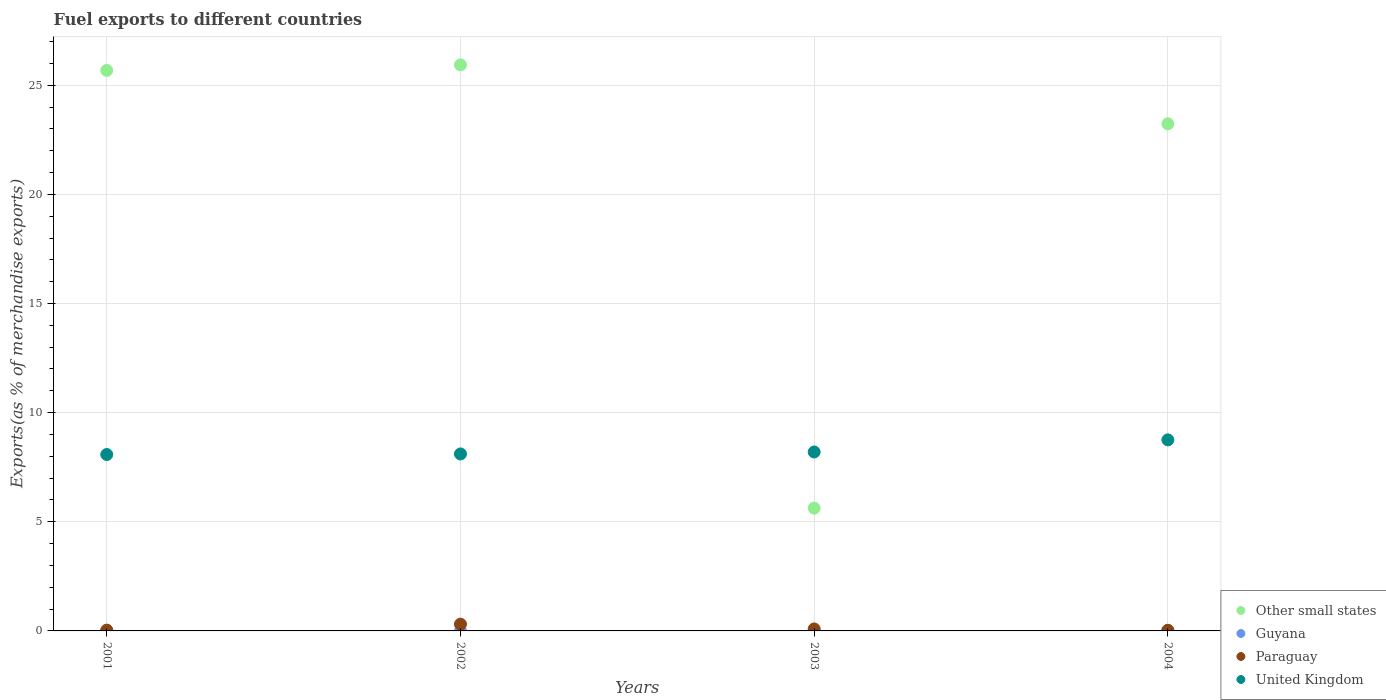What is the percentage of exports to different countries in Guyana in 2004?
Offer a terse response. 0.02. Across all years, what is the maximum percentage of exports to different countries in Guyana?
Your response must be concise. 0.02. Across all years, what is the minimum percentage of exports to different countries in Paraguay?
Your answer should be compact. 0.03. In which year was the percentage of exports to different countries in Guyana maximum?
Give a very brief answer. 2004. What is the total percentage of exports to different countries in United Kingdom in the graph?
Make the answer very short. 33.14. What is the difference between the percentage of exports to different countries in Paraguay in 2002 and that in 2004?
Ensure brevity in your answer.  0.28. What is the difference between the percentage of exports to different countries in Paraguay in 2002 and the percentage of exports to different countries in Other small states in 2001?
Offer a terse response. -25.37. What is the average percentage of exports to different countries in Paraguay per year?
Provide a succinct answer. 0.12. In the year 2003, what is the difference between the percentage of exports to different countries in Other small states and percentage of exports to different countries in Paraguay?
Make the answer very short. 5.53. What is the ratio of the percentage of exports to different countries in United Kingdom in 2002 to that in 2003?
Make the answer very short. 0.99. Is the difference between the percentage of exports to different countries in Other small states in 2001 and 2004 greater than the difference between the percentage of exports to different countries in Paraguay in 2001 and 2004?
Provide a succinct answer. Yes. What is the difference between the highest and the second highest percentage of exports to different countries in Paraguay?
Give a very brief answer. 0.22. What is the difference between the highest and the lowest percentage of exports to different countries in Guyana?
Your answer should be compact. 0.02. Is it the case that in every year, the sum of the percentage of exports to different countries in Guyana and percentage of exports to different countries in Paraguay  is greater than the sum of percentage of exports to different countries in Other small states and percentage of exports to different countries in United Kingdom?
Your answer should be very brief. No. Is it the case that in every year, the sum of the percentage of exports to different countries in Other small states and percentage of exports to different countries in Paraguay  is greater than the percentage of exports to different countries in United Kingdom?
Your answer should be compact. No. Does the percentage of exports to different countries in Paraguay monotonically increase over the years?
Offer a very short reply. No. Is the percentage of exports to different countries in Other small states strictly less than the percentage of exports to different countries in Guyana over the years?
Your answer should be very brief. No. How many years are there in the graph?
Offer a terse response. 4. What is the difference between two consecutive major ticks on the Y-axis?
Your answer should be compact. 5. Does the graph contain grids?
Provide a succinct answer. Yes. What is the title of the graph?
Give a very brief answer. Fuel exports to different countries. Does "Morocco" appear as one of the legend labels in the graph?
Make the answer very short. No. What is the label or title of the Y-axis?
Make the answer very short. Exports(as % of merchandise exports). What is the Exports(as % of merchandise exports) of Other small states in 2001?
Give a very brief answer. 25.68. What is the Exports(as % of merchandise exports) in Guyana in 2001?
Offer a very short reply. 0.01. What is the Exports(as % of merchandise exports) of Paraguay in 2001?
Give a very brief answer. 0.04. What is the Exports(as % of merchandise exports) of United Kingdom in 2001?
Offer a very short reply. 8.08. What is the Exports(as % of merchandise exports) in Other small states in 2002?
Provide a short and direct response. 25.93. What is the Exports(as % of merchandise exports) of Guyana in 2002?
Offer a terse response. 1.42119734312842e-5. What is the Exports(as % of merchandise exports) of Paraguay in 2002?
Make the answer very short. 0.31. What is the Exports(as % of merchandise exports) of United Kingdom in 2002?
Ensure brevity in your answer.  8.11. What is the Exports(as % of merchandise exports) in Other small states in 2003?
Your response must be concise. 5.63. What is the Exports(as % of merchandise exports) in Guyana in 2003?
Keep it short and to the point. 0. What is the Exports(as % of merchandise exports) in Paraguay in 2003?
Make the answer very short. 0.09. What is the Exports(as % of merchandise exports) in United Kingdom in 2003?
Offer a terse response. 8.2. What is the Exports(as % of merchandise exports) of Other small states in 2004?
Offer a very short reply. 23.23. What is the Exports(as % of merchandise exports) in Guyana in 2004?
Ensure brevity in your answer.  0.02. What is the Exports(as % of merchandise exports) of Paraguay in 2004?
Give a very brief answer. 0.03. What is the Exports(as % of merchandise exports) of United Kingdom in 2004?
Provide a succinct answer. 8.75. Across all years, what is the maximum Exports(as % of merchandise exports) of Other small states?
Give a very brief answer. 25.93. Across all years, what is the maximum Exports(as % of merchandise exports) of Guyana?
Give a very brief answer. 0.02. Across all years, what is the maximum Exports(as % of merchandise exports) in Paraguay?
Your answer should be very brief. 0.31. Across all years, what is the maximum Exports(as % of merchandise exports) of United Kingdom?
Make the answer very short. 8.75. Across all years, what is the minimum Exports(as % of merchandise exports) of Other small states?
Offer a terse response. 5.63. Across all years, what is the minimum Exports(as % of merchandise exports) of Guyana?
Provide a short and direct response. 1.42119734312842e-5. Across all years, what is the minimum Exports(as % of merchandise exports) of Paraguay?
Provide a short and direct response. 0.03. Across all years, what is the minimum Exports(as % of merchandise exports) of United Kingdom?
Your answer should be very brief. 8.08. What is the total Exports(as % of merchandise exports) in Other small states in the graph?
Provide a succinct answer. 80.47. What is the total Exports(as % of merchandise exports) in Guyana in the graph?
Ensure brevity in your answer.  0.03. What is the total Exports(as % of merchandise exports) in Paraguay in the graph?
Provide a succinct answer. 0.47. What is the total Exports(as % of merchandise exports) of United Kingdom in the graph?
Make the answer very short. 33.14. What is the difference between the Exports(as % of merchandise exports) of Other small states in 2001 and that in 2002?
Your response must be concise. -0.25. What is the difference between the Exports(as % of merchandise exports) of Guyana in 2001 and that in 2002?
Provide a short and direct response. 0.01. What is the difference between the Exports(as % of merchandise exports) in Paraguay in 2001 and that in 2002?
Offer a very short reply. -0.27. What is the difference between the Exports(as % of merchandise exports) in United Kingdom in 2001 and that in 2002?
Keep it short and to the point. -0.03. What is the difference between the Exports(as % of merchandise exports) of Other small states in 2001 and that in 2003?
Provide a short and direct response. 20.05. What is the difference between the Exports(as % of merchandise exports) of Guyana in 2001 and that in 2003?
Offer a very short reply. 0.01. What is the difference between the Exports(as % of merchandise exports) in Paraguay in 2001 and that in 2003?
Keep it short and to the point. -0.05. What is the difference between the Exports(as % of merchandise exports) in United Kingdom in 2001 and that in 2003?
Your answer should be very brief. -0.12. What is the difference between the Exports(as % of merchandise exports) of Other small states in 2001 and that in 2004?
Your response must be concise. 2.45. What is the difference between the Exports(as % of merchandise exports) of Guyana in 2001 and that in 2004?
Offer a terse response. -0.01. What is the difference between the Exports(as % of merchandise exports) of Paraguay in 2001 and that in 2004?
Provide a succinct answer. 0.01. What is the difference between the Exports(as % of merchandise exports) of United Kingdom in 2001 and that in 2004?
Keep it short and to the point. -0.67. What is the difference between the Exports(as % of merchandise exports) in Other small states in 2002 and that in 2003?
Provide a succinct answer. 20.31. What is the difference between the Exports(as % of merchandise exports) in Guyana in 2002 and that in 2003?
Provide a succinct answer. -0. What is the difference between the Exports(as % of merchandise exports) of Paraguay in 2002 and that in 2003?
Ensure brevity in your answer.  0.22. What is the difference between the Exports(as % of merchandise exports) in United Kingdom in 2002 and that in 2003?
Make the answer very short. -0.09. What is the difference between the Exports(as % of merchandise exports) in Other small states in 2002 and that in 2004?
Offer a very short reply. 2.7. What is the difference between the Exports(as % of merchandise exports) in Guyana in 2002 and that in 2004?
Your answer should be very brief. -0.02. What is the difference between the Exports(as % of merchandise exports) of Paraguay in 2002 and that in 2004?
Offer a very short reply. 0.28. What is the difference between the Exports(as % of merchandise exports) in United Kingdom in 2002 and that in 2004?
Your answer should be compact. -0.65. What is the difference between the Exports(as % of merchandise exports) in Other small states in 2003 and that in 2004?
Provide a short and direct response. -17.61. What is the difference between the Exports(as % of merchandise exports) in Guyana in 2003 and that in 2004?
Your answer should be compact. -0.02. What is the difference between the Exports(as % of merchandise exports) of Paraguay in 2003 and that in 2004?
Offer a terse response. 0.06. What is the difference between the Exports(as % of merchandise exports) of United Kingdom in 2003 and that in 2004?
Give a very brief answer. -0.56. What is the difference between the Exports(as % of merchandise exports) in Other small states in 2001 and the Exports(as % of merchandise exports) in Guyana in 2002?
Your answer should be very brief. 25.68. What is the difference between the Exports(as % of merchandise exports) of Other small states in 2001 and the Exports(as % of merchandise exports) of Paraguay in 2002?
Your answer should be compact. 25.37. What is the difference between the Exports(as % of merchandise exports) of Other small states in 2001 and the Exports(as % of merchandise exports) of United Kingdom in 2002?
Give a very brief answer. 17.57. What is the difference between the Exports(as % of merchandise exports) in Guyana in 2001 and the Exports(as % of merchandise exports) in Paraguay in 2002?
Your answer should be very brief. -0.3. What is the difference between the Exports(as % of merchandise exports) in Guyana in 2001 and the Exports(as % of merchandise exports) in United Kingdom in 2002?
Your answer should be compact. -8.1. What is the difference between the Exports(as % of merchandise exports) of Paraguay in 2001 and the Exports(as % of merchandise exports) of United Kingdom in 2002?
Your answer should be compact. -8.07. What is the difference between the Exports(as % of merchandise exports) in Other small states in 2001 and the Exports(as % of merchandise exports) in Guyana in 2003?
Provide a succinct answer. 25.68. What is the difference between the Exports(as % of merchandise exports) of Other small states in 2001 and the Exports(as % of merchandise exports) of Paraguay in 2003?
Your answer should be compact. 25.59. What is the difference between the Exports(as % of merchandise exports) in Other small states in 2001 and the Exports(as % of merchandise exports) in United Kingdom in 2003?
Offer a terse response. 17.48. What is the difference between the Exports(as % of merchandise exports) of Guyana in 2001 and the Exports(as % of merchandise exports) of Paraguay in 2003?
Your answer should be very brief. -0.08. What is the difference between the Exports(as % of merchandise exports) in Guyana in 2001 and the Exports(as % of merchandise exports) in United Kingdom in 2003?
Your answer should be very brief. -8.19. What is the difference between the Exports(as % of merchandise exports) in Paraguay in 2001 and the Exports(as % of merchandise exports) in United Kingdom in 2003?
Offer a terse response. -8.16. What is the difference between the Exports(as % of merchandise exports) of Other small states in 2001 and the Exports(as % of merchandise exports) of Guyana in 2004?
Offer a very short reply. 25.66. What is the difference between the Exports(as % of merchandise exports) in Other small states in 2001 and the Exports(as % of merchandise exports) in Paraguay in 2004?
Your answer should be very brief. 25.65. What is the difference between the Exports(as % of merchandise exports) of Other small states in 2001 and the Exports(as % of merchandise exports) of United Kingdom in 2004?
Give a very brief answer. 16.93. What is the difference between the Exports(as % of merchandise exports) in Guyana in 2001 and the Exports(as % of merchandise exports) in Paraguay in 2004?
Your answer should be compact. -0.02. What is the difference between the Exports(as % of merchandise exports) of Guyana in 2001 and the Exports(as % of merchandise exports) of United Kingdom in 2004?
Your response must be concise. -8.74. What is the difference between the Exports(as % of merchandise exports) of Paraguay in 2001 and the Exports(as % of merchandise exports) of United Kingdom in 2004?
Give a very brief answer. -8.72. What is the difference between the Exports(as % of merchandise exports) of Other small states in 2002 and the Exports(as % of merchandise exports) of Guyana in 2003?
Your answer should be very brief. 25.93. What is the difference between the Exports(as % of merchandise exports) in Other small states in 2002 and the Exports(as % of merchandise exports) in Paraguay in 2003?
Give a very brief answer. 25.84. What is the difference between the Exports(as % of merchandise exports) in Other small states in 2002 and the Exports(as % of merchandise exports) in United Kingdom in 2003?
Keep it short and to the point. 17.73. What is the difference between the Exports(as % of merchandise exports) in Guyana in 2002 and the Exports(as % of merchandise exports) in Paraguay in 2003?
Provide a succinct answer. -0.09. What is the difference between the Exports(as % of merchandise exports) of Guyana in 2002 and the Exports(as % of merchandise exports) of United Kingdom in 2003?
Keep it short and to the point. -8.2. What is the difference between the Exports(as % of merchandise exports) of Paraguay in 2002 and the Exports(as % of merchandise exports) of United Kingdom in 2003?
Your answer should be compact. -7.89. What is the difference between the Exports(as % of merchandise exports) in Other small states in 2002 and the Exports(as % of merchandise exports) in Guyana in 2004?
Offer a very short reply. 25.91. What is the difference between the Exports(as % of merchandise exports) in Other small states in 2002 and the Exports(as % of merchandise exports) in Paraguay in 2004?
Offer a very short reply. 25.9. What is the difference between the Exports(as % of merchandise exports) of Other small states in 2002 and the Exports(as % of merchandise exports) of United Kingdom in 2004?
Make the answer very short. 17.18. What is the difference between the Exports(as % of merchandise exports) in Guyana in 2002 and the Exports(as % of merchandise exports) in Paraguay in 2004?
Provide a short and direct response. -0.03. What is the difference between the Exports(as % of merchandise exports) in Guyana in 2002 and the Exports(as % of merchandise exports) in United Kingdom in 2004?
Make the answer very short. -8.75. What is the difference between the Exports(as % of merchandise exports) in Paraguay in 2002 and the Exports(as % of merchandise exports) in United Kingdom in 2004?
Your response must be concise. -8.44. What is the difference between the Exports(as % of merchandise exports) of Other small states in 2003 and the Exports(as % of merchandise exports) of Guyana in 2004?
Offer a very short reply. 5.6. What is the difference between the Exports(as % of merchandise exports) in Other small states in 2003 and the Exports(as % of merchandise exports) in Paraguay in 2004?
Provide a short and direct response. 5.6. What is the difference between the Exports(as % of merchandise exports) of Other small states in 2003 and the Exports(as % of merchandise exports) of United Kingdom in 2004?
Provide a succinct answer. -3.13. What is the difference between the Exports(as % of merchandise exports) in Guyana in 2003 and the Exports(as % of merchandise exports) in Paraguay in 2004?
Ensure brevity in your answer.  -0.03. What is the difference between the Exports(as % of merchandise exports) in Guyana in 2003 and the Exports(as % of merchandise exports) in United Kingdom in 2004?
Offer a very short reply. -8.75. What is the difference between the Exports(as % of merchandise exports) in Paraguay in 2003 and the Exports(as % of merchandise exports) in United Kingdom in 2004?
Your answer should be very brief. -8.66. What is the average Exports(as % of merchandise exports) of Other small states per year?
Ensure brevity in your answer.  20.12. What is the average Exports(as % of merchandise exports) in Guyana per year?
Offer a very short reply. 0.01. What is the average Exports(as % of merchandise exports) in Paraguay per year?
Make the answer very short. 0.12. What is the average Exports(as % of merchandise exports) of United Kingdom per year?
Offer a terse response. 8.29. In the year 2001, what is the difference between the Exports(as % of merchandise exports) in Other small states and Exports(as % of merchandise exports) in Guyana?
Your answer should be compact. 25.67. In the year 2001, what is the difference between the Exports(as % of merchandise exports) in Other small states and Exports(as % of merchandise exports) in Paraguay?
Give a very brief answer. 25.64. In the year 2001, what is the difference between the Exports(as % of merchandise exports) of Other small states and Exports(as % of merchandise exports) of United Kingdom?
Provide a short and direct response. 17.6. In the year 2001, what is the difference between the Exports(as % of merchandise exports) in Guyana and Exports(as % of merchandise exports) in Paraguay?
Your answer should be very brief. -0.03. In the year 2001, what is the difference between the Exports(as % of merchandise exports) of Guyana and Exports(as % of merchandise exports) of United Kingdom?
Make the answer very short. -8.07. In the year 2001, what is the difference between the Exports(as % of merchandise exports) in Paraguay and Exports(as % of merchandise exports) in United Kingdom?
Give a very brief answer. -8.04. In the year 2002, what is the difference between the Exports(as % of merchandise exports) in Other small states and Exports(as % of merchandise exports) in Guyana?
Keep it short and to the point. 25.93. In the year 2002, what is the difference between the Exports(as % of merchandise exports) of Other small states and Exports(as % of merchandise exports) of Paraguay?
Offer a terse response. 25.62. In the year 2002, what is the difference between the Exports(as % of merchandise exports) in Other small states and Exports(as % of merchandise exports) in United Kingdom?
Your answer should be very brief. 17.82. In the year 2002, what is the difference between the Exports(as % of merchandise exports) of Guyana and Exports(as % of merchandise exports) of Paraguay?
Keep it short and to the point. -0.31. In the year 2002, what is the difference between the Exports(as % of merchandise exports) of Guyana and Exports(as % of merchandise exports) of United Kingdom?
Your response must be concise. -8.11. In the year 2002, what is the difference between the Exports(as % of merchandise exports) of Paraguay and Exports(as % of merchandise exports) of United Kingdom?
Provide a short and direct response. -7.8. In the year 2003, what is the difference between the Exports(as % of merchandise exports) of Other small states and Exports(as % of merchandise exports) of Guyana?
Keep it short and to the point. 5.62. In the year 2003, what is the difference between the Exports(as % of merchandise exports) in Other small states and Exports(as % of merchandise exports) in Paraguay?
Your response must be concise. 5.53. In the year 2003, what is the difference between the Exports(as % of merchandise exports) in Other small states and Exports(as % of merchandise exports) in United Kingdom?
Provide a succinct answer. -2.57. In the year 2003, what is the difference between the Exports(as % of merchandise exports) of Guyana and Exports(as % of merchandise exports) of Paraguay?
Your answer should be very brief. -0.09. In the year 2003, what is the difference between the Exports(as % of merchandise exports) in Guyana and Exports(as % of merchandise exports) in United Kingdom?
Provide a succinct answer. -8.2. In the year 2003, what is the difference between the Exports(as % of merchandise exports) of Paraguay and Exports(as % of merchandise exports) of United Kingdom?
Provide a short and direct response. -8.11. In the year 2004, what is the difference between the Exports(as % of merchandise exports) of Other small states and Exports(as % of merchandise exports) of Guyana?
Offer a very short reply. 23.21. In the year 2004, what is the difference between the Exports(as % of merchandise exports) in Other small states and Exports(as % of merchandise exports) in Paraguay?
Keep it short and to the point. 23.2. In the year 2004, what is the difference between the Exports(as % of merchandise exports) in Other small states and Exports(as % of merchandise exports) in United Kingdom?
Your response must be concise. 14.48. In the year 2004, what is the difference between the Exports(as % of merchandise exports) of Guyana and Exports(as % of merchandise exports) of Paraguay?
Keep it short and to the point. -0.01. In the year 2004, what is the difference between the Exports(as % of merchandise exports) of Guyana and Exports(as % of merchandise exports) of United Kingdom?
Provide a succinct answer. -8.73. In the year 2004, what is the difference between the Exports(as % of merchandise exports) of Paraguay and Exports(as % of merchandise exports) of United Kingdom?
Make the answer very short. -8.72. What is the ratio of the Exports(as % of merchandise exports) in Other small states in 2001 to that in 2002?
Your answer should be very brief. 0.99. What is the ratio of the Exports(as % of merchandise exports) in Guyana in 2001 to that in 2002?
Keep it short and to the point. 569.49. What is the ratio of the Exports(as % of merchandise exports) of Paraguay in 2001 to that in 2002?
Provide a succinct answer. 0.12. What is the ratio of the Exports(as % of merchandise exports) of United Kingdom in 2001 to that in 2002?
Give a very brief answer. 1. What is the ratio of the Exports(as % of merchandise exports) of Other small states in 2001 to that in 2003?
Make the answer very short. 4.56. What is the ratio of the Exports(as % of merchandise exports) in Guyana in 2001 to that in 2003?
Your answer should be very brief. 5.46. What is the ratio of the Exports(as % of merchandise exports) of Paraguay in 2001 to that in 2003?
Your response must be concise. 0.4. What is the ratio of the Exports(as % of merchandise exports) of United Kingdom in 2001 to that in 2003?
Give a very brief answer. 0.99. What is the ratio of the Exports(as % of merchandise exports) of Other small states in 2001 to that in 2004?
Offer a very short reply. 1.11. What is the ratio of the Exports(as % of merchandise exports) in Guyana in 2001 to that in 2004?
Ensure brevity in your answer.  0.37. What is the ratio of the Exports(as % of merchandise exports) in Paraguay in 2001 to that in 2004?
Your answer should be compact. 1.27. What is the ratio of the Exports(as % of merchandise exports) of United Kingdom in 2001 to that in 2004?
Provide a succinct answer. 0.92. What is the ratio of the Exports(as % of merchandise exports) in Other small states in 2002 to that in 2003?
Offer a very short reply. 4.61. What is the ratio of the Exports(as % of merchandise exports) of Guyana in 2002 to that in 2003?
Make the answer very short. 0.01. What is the ratio of the Exports(as % of merchandise exports) in Paraguay in 2002 to that in 2003?
Make the answer very short. 3.4. What is the ratio of the Exports(as % of merchandise exports) in United Kingdom in 2002 to that in 2003?
Your answer should be very brief. 0.99. What is the ratio of the Exports(as % of merchandise exports) of Other small states in 2002 to that in 2004?
Your response must be concise. 1.12. What is the ratio of the Exports(as % of merchandise exports) of Guyana in 2002 to that in 2004?
Make the answer very short. 0. What is the ratio of the Exports(as % of merchandise exports) in Paraguay in 2002 to that in 2004?
Keep it short and to the point. 10.74. What is the ratio of the Exports(as % of merchandise exports) in United Kingdom in 2002 to that in 2004?
Give a very brief answer. 0.93. What is the ratio of the Exports(as % of merchandise exports) in Other small states in 2003 to that in 2004?
Provide a short and direct response. 0.24. What is the ratio of the Exports(as % of merchandise exports) in Guyana in 2003 to that in 2004?
Offer a very short reply. 0.07. What is the ratio of the Exports(as % of merchandise exports) in Paraguay in 2003 to that in 2004?
Keep it short and to the point. 3.15. What is the ratio of the Exports(as % of merchandise exports) of United Kingdom in 2003 to that in 2004?
Keep it short and to the point. 0.94. What is the difference between the highest and the second highest Exports(as % of merchandise exports) in Other small states?
Give a very brief answer. 0.25. What is the difference between the highest and the second highest Exports(as % of merchandise exports) of Guyana?
Ensure brevity in your answer.  0.01. What is the difference between the highest and the second highest Exports(as % of merchandise exports) in Paraguay?
Ensure brevity in your answer.  0.22. What is the difference between the highest and the second highest Exports(as % of merchandise exports) of United Kingdom?
Give a very brief answer. 0.56. What is the difference between the highest and the lowest Exports(as % of merchandise exports) in Other small states?
Offer a very short reply. 20.31. What is the difference between the highest and the lowest Exports(as % of merchandise exports) in Guyana?
Your answer should be very brief. 0.02. What is the difference between the highest and the lowest Exports(as % of merchandise exports) in Paraguay?
Give a very brief answer. 0.28. What is the difference between the highest and the lowest Exports(as % of merchandise exports) in United Kingdom?
Your answer should be compact. 0.67. 